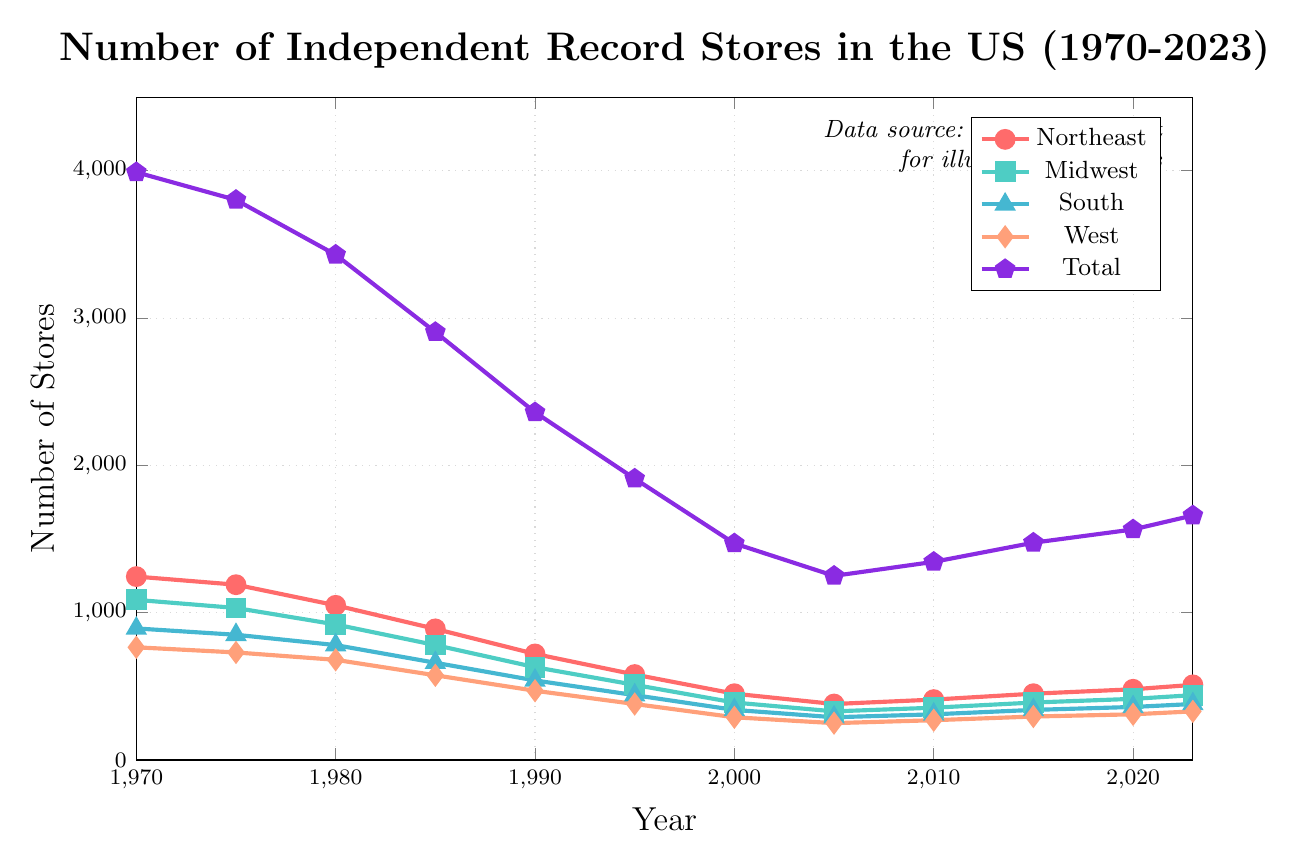What was the total number of independent record stores in the US in 1980? To find this, look at the "Total" line for the year 1980.
Answer: 3430 Between which two regions was the drop in the number of independent record stores from 1970 to 2000 the largest? Calculate the difference between 1970 and 2000 for each region: Northeast (1245-450=795), Midwest (1087-390=697), South (893-340=553), and West (765-290=475). The largest drop is in the Northeast.
Answer: Northeast In which region did the number of independent record stores start increasing again after a period of decline, and can you identify the years of decline and growth? Looking at the plot for each region, the Northeast starts increasing after 2005 (lowest point). Decline years: 1970-2005; Growth years: 2005-2023.
Answer: Northeast What is the difference in the number of independent record stores in the South between 1990 and 2023? Subtract the number in 1990 from the number in 2023 for the South region: 380 - 540 = -160.
Answer: -160 Between which consecutive five-year intervals did the West experience the smallest decline in the number of record stores, and what were the numbers? Examine each consecutive five-year change for West: 
1970-1975: 765 to 730, change = -35 
1975-1980: 730 to 680, change = -50 
1980-1985: 680 to 575, change = -105 
1985-1990: 575 to 470, change = -105 
1990-1995: 470 to 380, change = -90 
1995-2000: 380 to 290, change = -90 
2000-2005: 290 to 250, change = -40 
The smallest decline is from 1970 to 1975.
Answer: 1970 to 1975 How does the trend of total independent record stores compare to that of any specific region from 2000 to 2023? Observe that both the "Total" and regional lines (e.g., Northeast) rise from 2000 onwards, but the total reflects the combined regional trends. For regions such as the Northeast, the trend aligns with the overall upward growth after 2000.
Answer: Similar upward trend Which region had the least number of independent record stores in 1980 and how many were there? Compare the number of record stores for each region in 1980: Northeast (1050), Midwest (920), South (780), West (680). The West had the least with 680 stores.
Answer: West, 680 What was the total drop in the number of independent record stores in the Midwest from 1970 to 1990? Calculate the drop by subtracting the 1990 figure from the 1970 figure for the Midwest: 1087 - 630 = 457.
Answer: 457 How did the number of record stores in the Northeast change from 2010 to 2023? Compare the number of record stores for the Northeast in 2010 and 2023: 510 - 410 = 100.
Answer: Increased by 100 